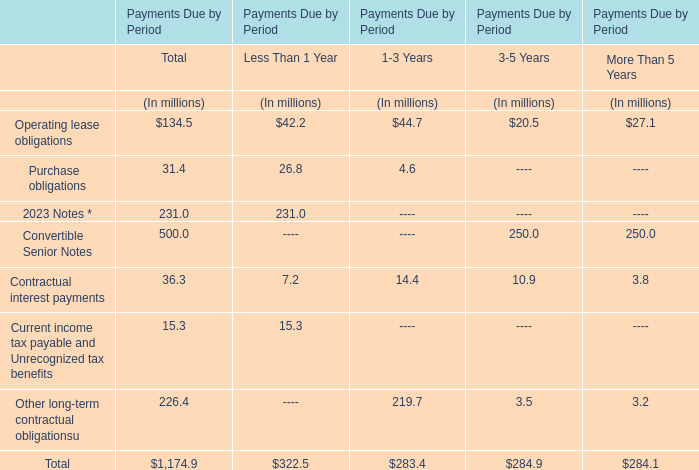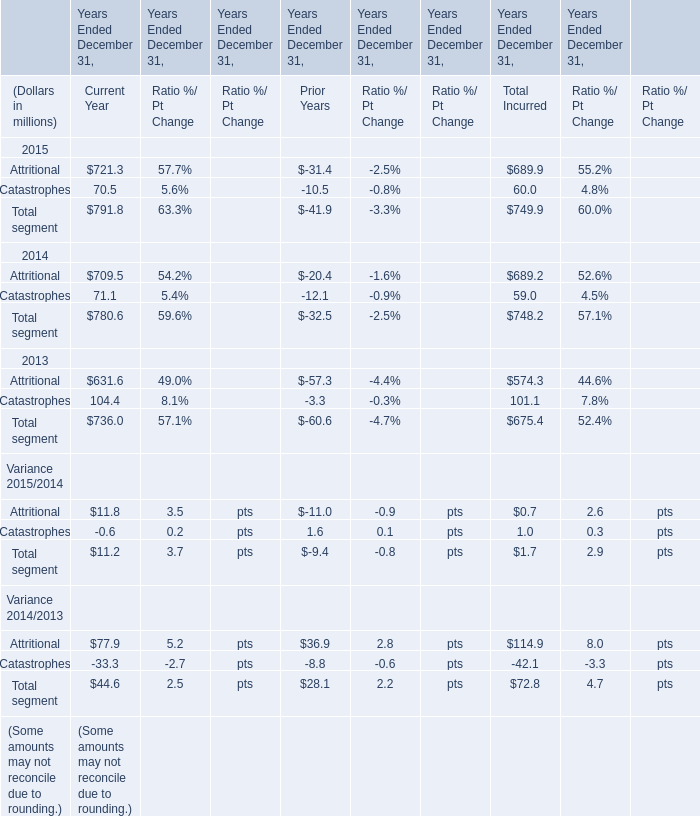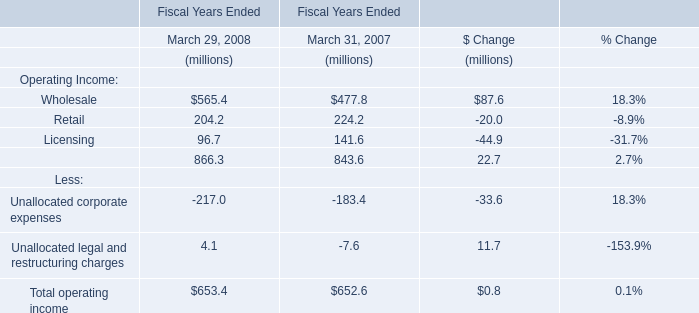As As the chart 1 shows,which Year Ended December 31 is the value of the amount for Total Incurred for Catastrophes the lowest? 
Answer: 2014. 